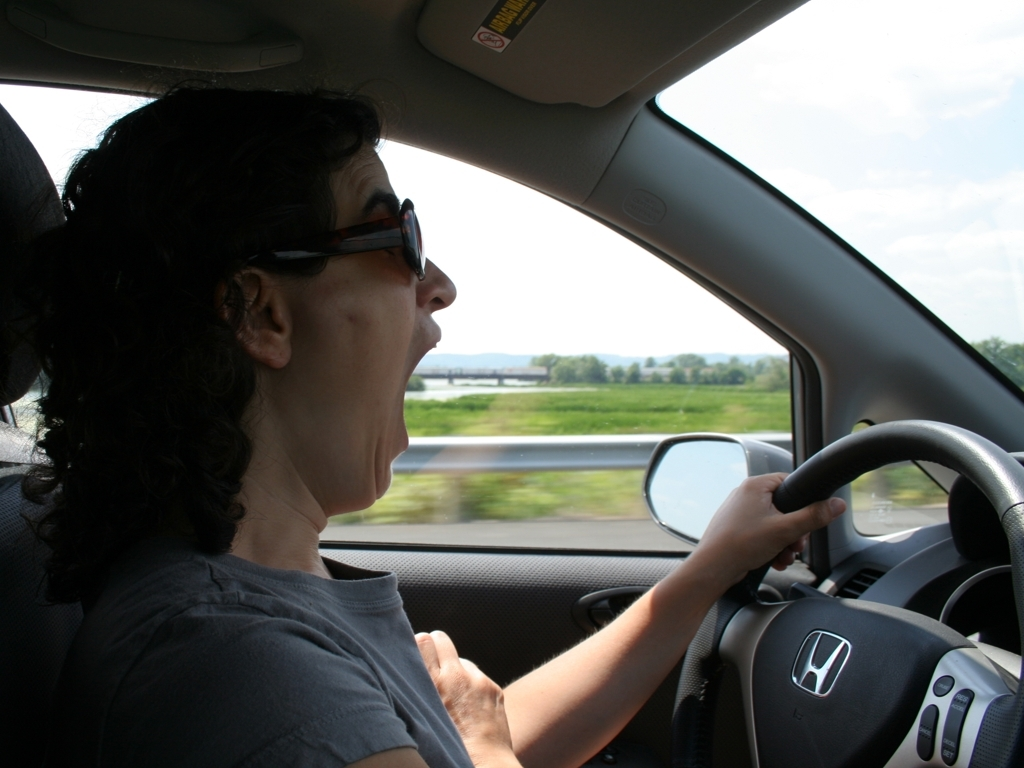Can you describe what the person in the image might be doing? The person in the image appears to be driving a vehicle. You can infer this from the placement of their hands on the steering wheel and the scenery passing by outside the car windows. What can we tell about the weather outside from the image? Based on the brightness and visibility in the image, it suggests a sunny or clear day. The sky is visible through the window and appears to be quite bright, indicating there are likely few clouds obstructing the sunlight. 